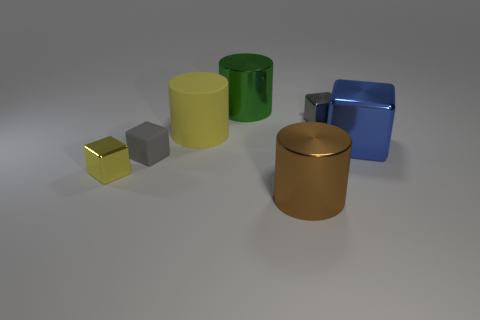Can you describe the lighting in the scene? The lighting in the image is soft and diffused, coming from above. It casts soft shadows directly beneath the objects, suggesting an overhead ambient light source, which provides even illumination without harsh highlights. 